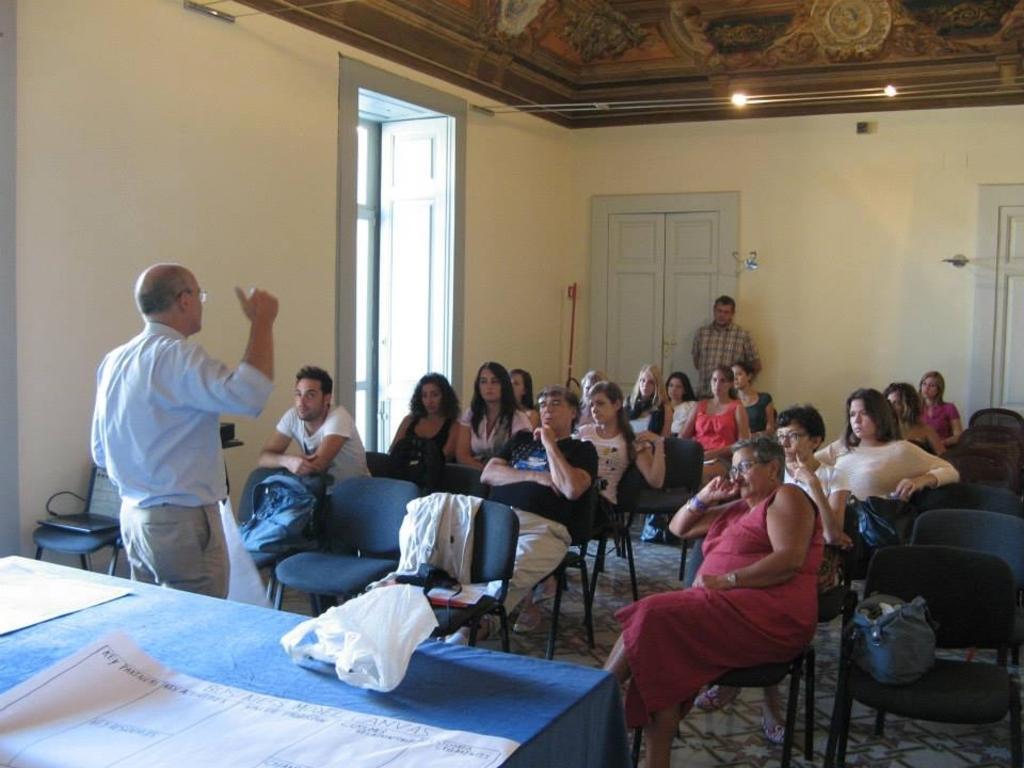Could you give a brief overview of what you see in this image? There is a group of people. They are sitting on a chair. Two persons are standing. We can see in background light,window and door. 